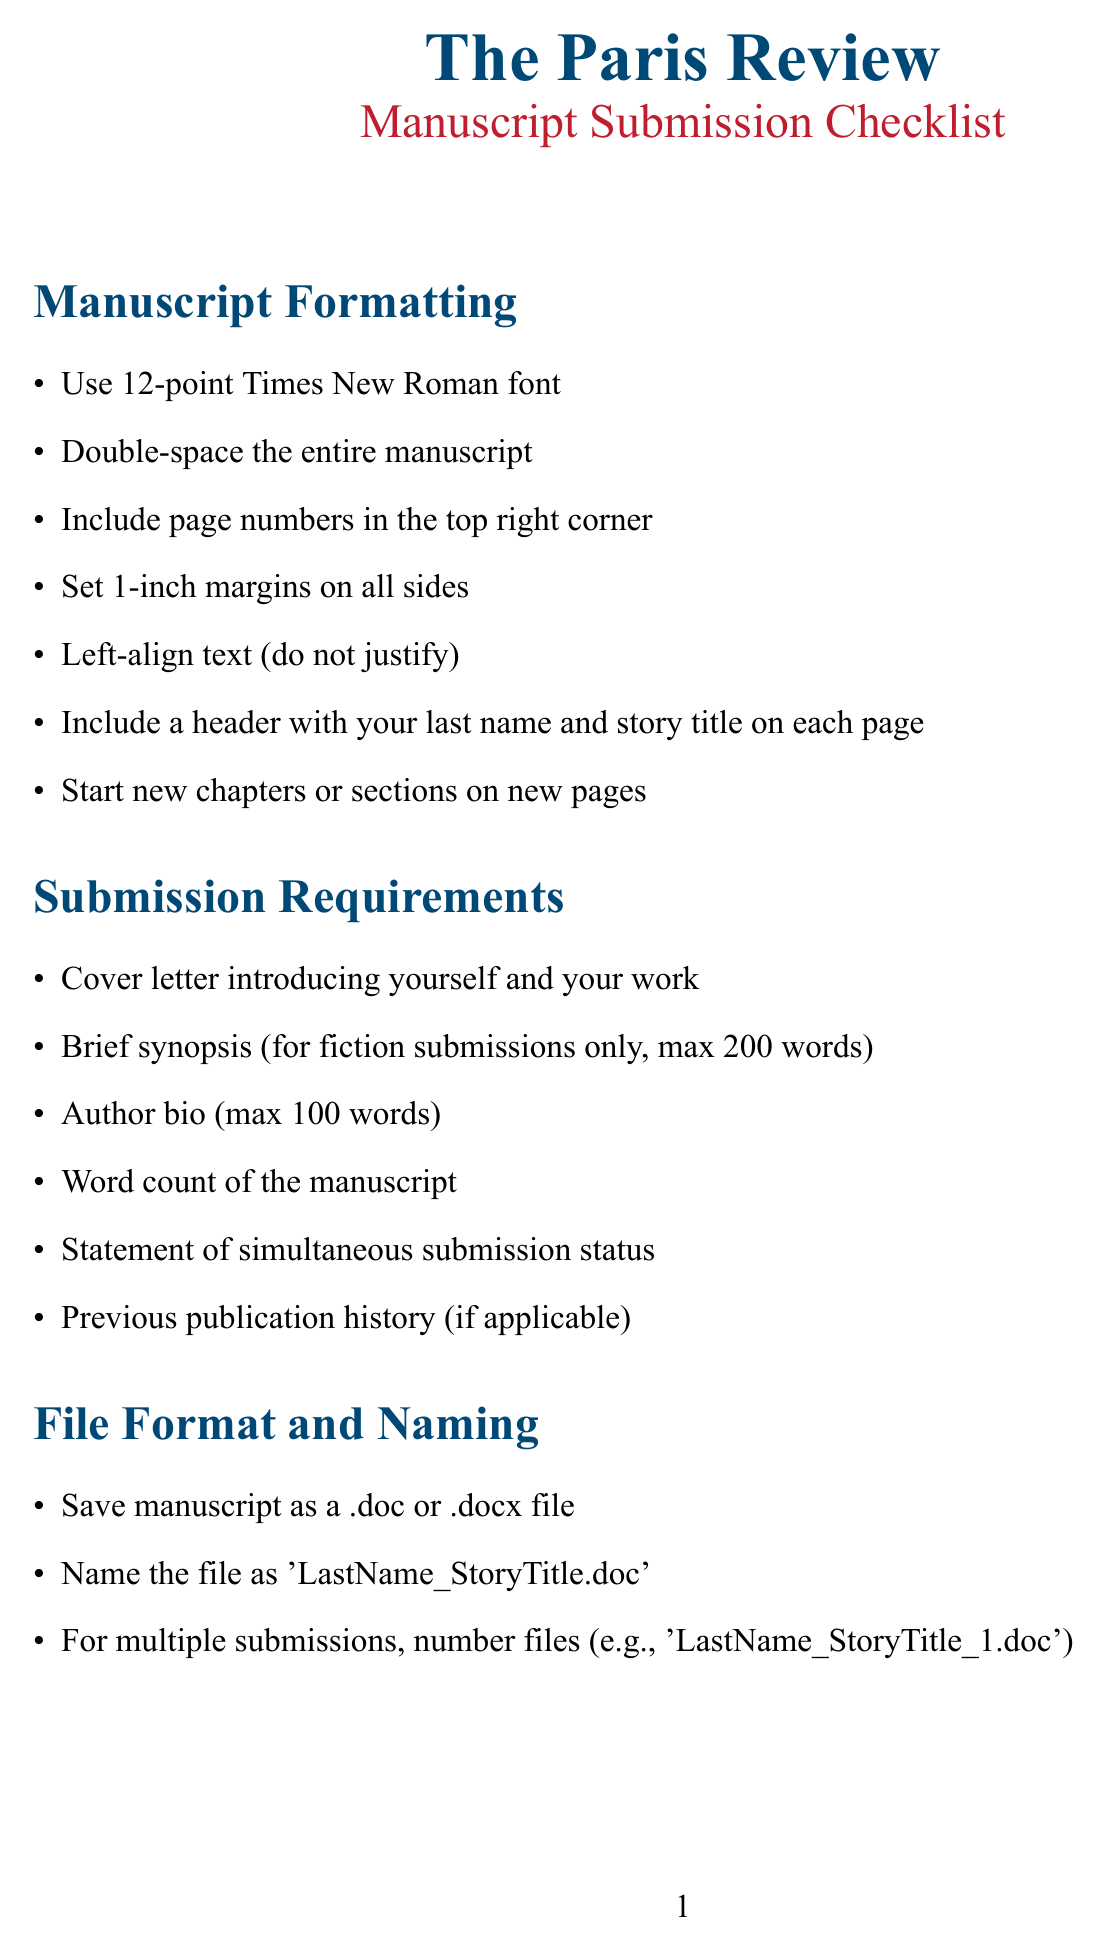What is the submission deadline? The submission deadline is specifically stated in the document under the key information section.
Answer: June 30, 2023 Who is the Editor-in-Chief? The document lists the names and positions of the editorial team, identifying the Editor-in-Chief.
Answer: Emily Nemens What is the maximum word count for fiction submissions? The word count guidelines for fiction submissions are clearly outlined in the genre-specific guidelines section.
Answer: 3,000-7,000 words What file formats are acceptable for manuscript submission? The document specifies the accepted file formats in the file format and naming section.
Answer: .doc or .docx What is the submission fee? The document mentions any fees associated with the submission process, specifically stated in the submission process section.
Answer: $3 Name one common mistake authors make when submitting. The document provides a list of common mistakes to avoid, which can be found in that specific section.
Answer: Ignoring specific formatting guidelines What should be included in the cover letter? The document outlines the components required for a cover letter in the submission requirements section.
Answer: Introducing yourself and your work How long is the expected response time for submissions? The response time is provided under key information in the document, which specifies how long authors might wait.
Answer: 8-12 weeks 